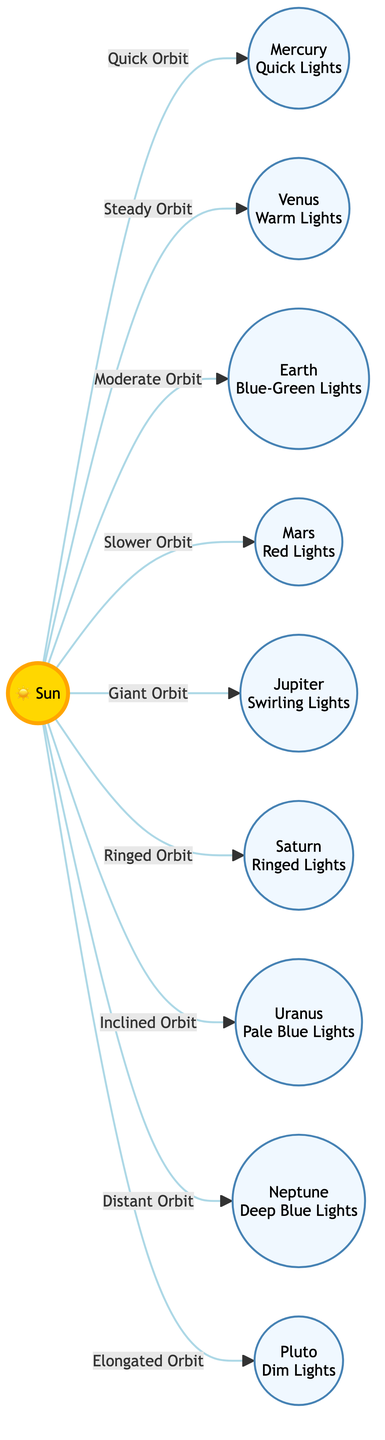What is the color of lights associated with Venus? The diagram indicates that Venus has "Warm Lights" associated with it. This is read directly from the node connected to Venus.
Answer: Warm Lights How many planets are directly connected to the Sun? Counting the nodes connected to the Sun, we see nine connections (including Pluto). Therefore, there are eight planets linked.
Answer: Eight What type of orbit does Mars have? The diagram specifies that Mars has a "Slower Orbit" in its connection with the Sun. This information is indicated on the arrow leading from the Sun to Mars.
Answer: Slower Orbit Which planet is associated with swirling lights? According to the diagram, Jupiter is associated with "Swirling Lights." This is found in the description attached to the Jupiter node.
Answer: Swirling Lights What is the relationship between the Sun and Pluto? The relationship indicated is that of an "Elongated Orbit" between the Sun and Pluto, as shown in the diagram.
Answer: Elongated Orbit How many types of lighting are described in the diagram? The planets listed each have a unique lighting style associated with them, resulting in a total of nine types of lighting when accounting for all planets, including Pluto.
Answer: Nine Which planet has the dimmest lights according to the diagram? Pluto is indicated as having "Dim Lights," which is explicitly described in the node corresponding to Pluto.
Answer: Dim Lights What color lights does Earth emit? The diagram states that Earth has "Blue-Green Lights." This can be found in the description next to the Earth node.
Answer: Blue-Green Lights What orbital characteristic does Saturn have? The diagram notes that Saturn is associated with "Ringed Orbit," denoting an important descriptive feature of the orbital relationship with the Sun.
Answer: Ringed Orbit 